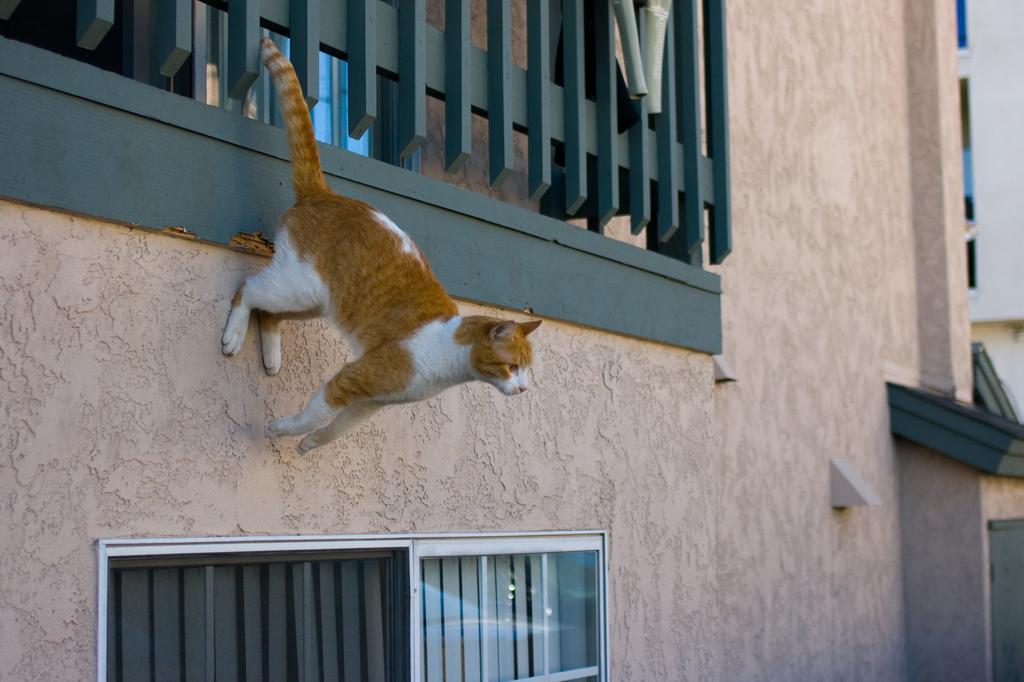How would you summarize this image in a sentence or two? In this image I can see a brown and white colour cat on the building's wall. I can also see windows on the bottom side of the image. 